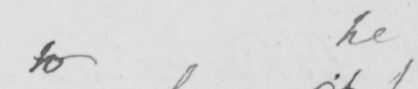What text is written in this handwritten line? to he 